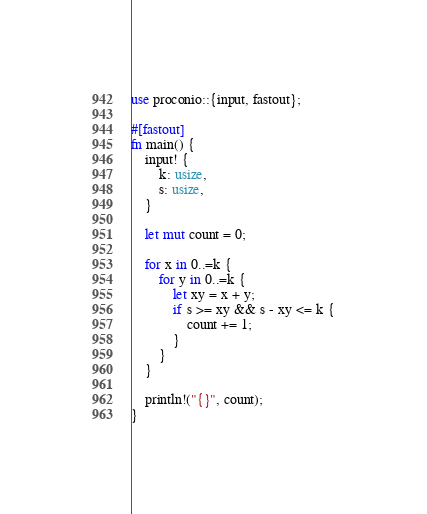Convert code to text. <code><loc_0><loc_0><loc_500><loc_500><_Rust_>use proconio::{input, fastout};

#[fastout]
fn main() {
    input! {
        k: usize,
        s: usize,
    }

    let mut count = 0;

    for x in 0..=k {
        for y in 0..=k {
            let xy = x + y;
            if s >= xy && s - xy <= k {
                count += 1;
            }
        }
    }

    println!("{}", count);
}</code> 